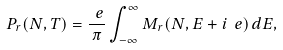Convert formula to latex. <formula><loc_0><loc_0><loc_500><loc_500>P _ { r } ( N , T ) = \frac { \ e } { \pi } \int _ { - \infty } ^ { \infty } M _ { r } ( N , E + i \ e ) \, d E ,</formula> 